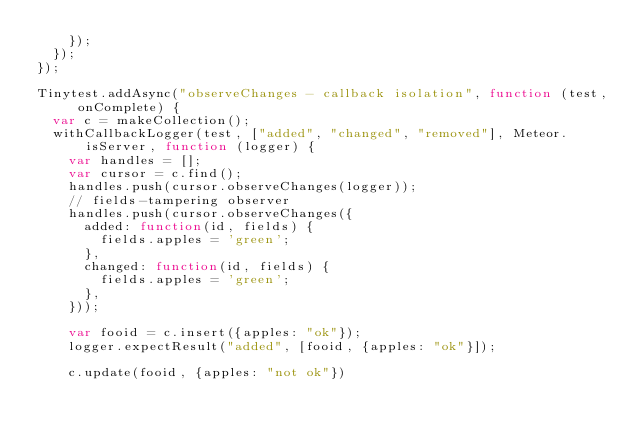Convert code to text. <code><loc_0><loc_0><loc_500><loc_500><_JavaScript_>    });
  });
});

Tinytest.addAsync("observeChanges - callback isolation", function (test, onComplete) {
  var c = makeCollection();
  withCallbackLogger(test, ["added", "changed", "removed"], Meteor.isServer, function (logger) {
    var handles = [];
    var cursor = c.find();
    handles.push(cursor.observeChanges(logger));
    // fields-tampering observer
    handles.push(cursor.observeChanges({
      added: function(id, fields) {
        fields.apples = 'green';
      },
      changed: function(id, fields) {
        fields.apples = 'green';
      },
    }));

    var fooid = c.insert({apples: "ok"});
    logger.expectResult("added", [fooid, {apples: "ok"}]);

    c.update(fooid, {apples: "not ok"})</code> 